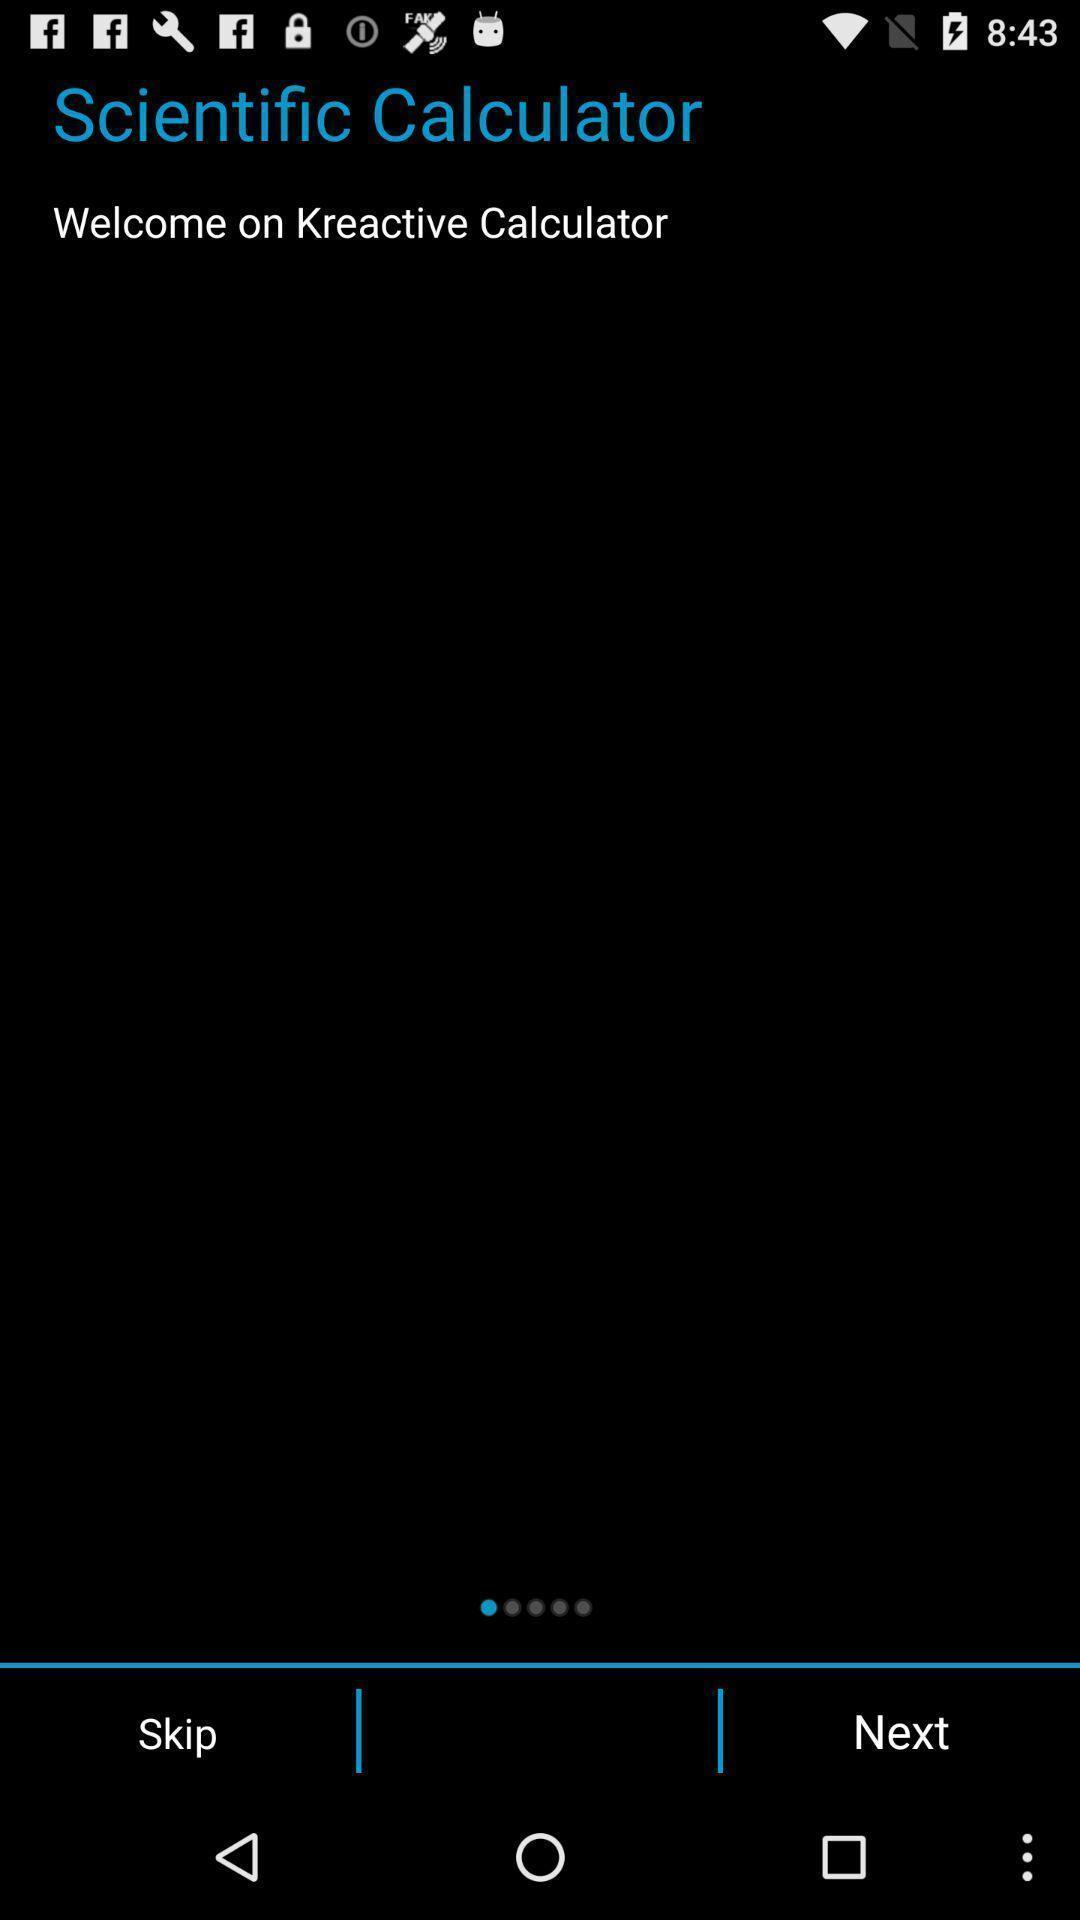Summarize the information in this screenshot. Welcome page. 